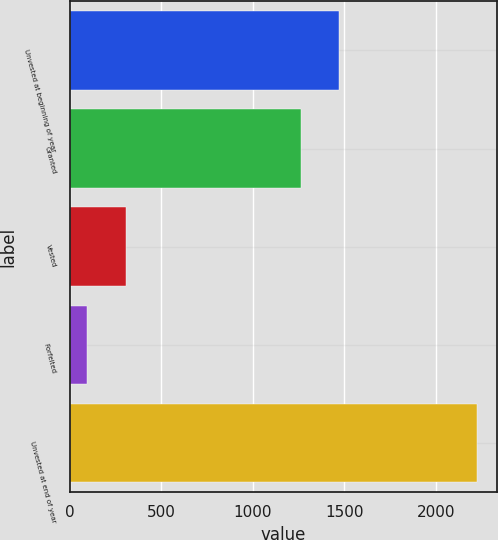<chart> <loc_0><loc_0><loc_500><loc_500><bar_chart><fcel>Unvested at beginning of year<fcel>Granted<fcel>Vested<fcel>Forfeited<fcel>Unvested at end of year<nl><fcel>1473.8<fcel>1261<fcel>307.8<fcel>95<fcel>2223<nl></chart> 